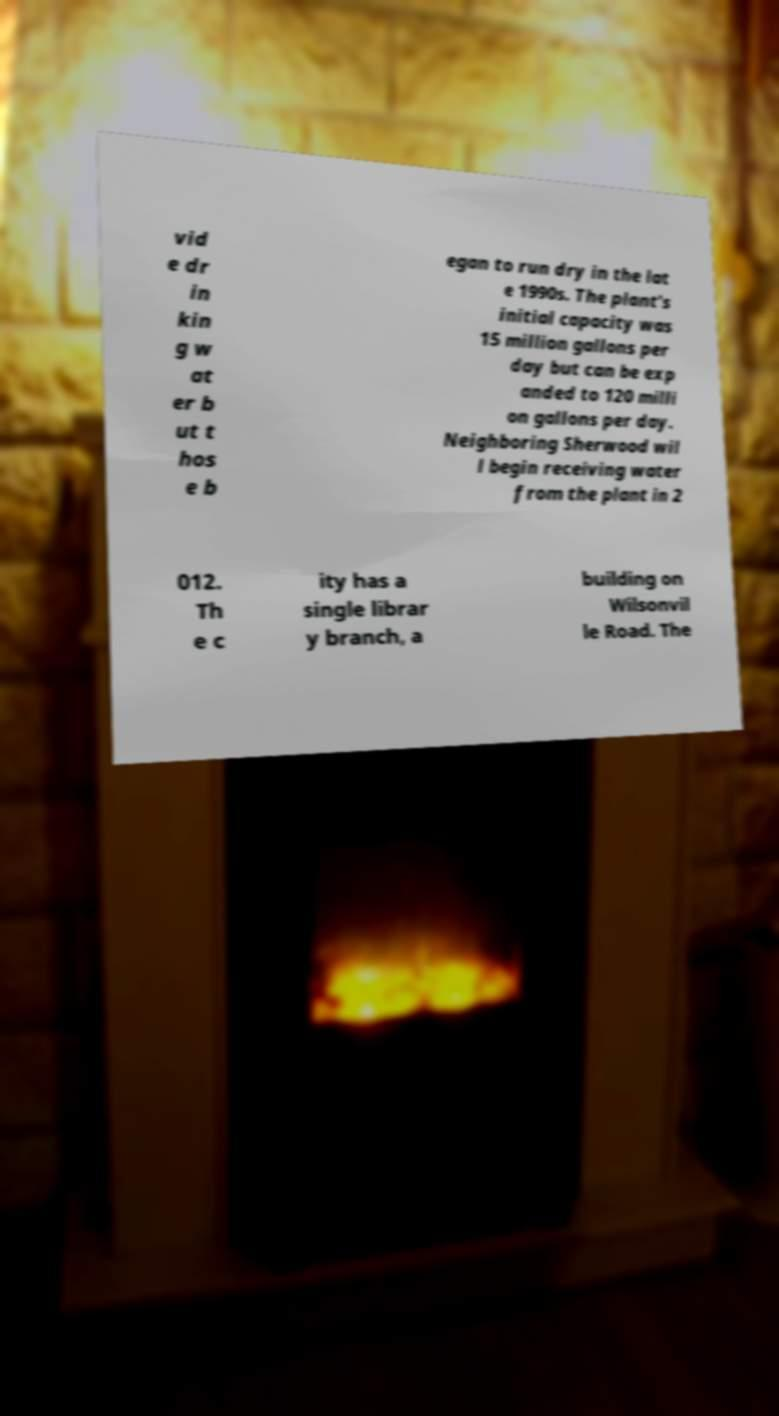Can you read and provide the text displayed in the image?This photo seems to have some interesting text. Can you extract and type it out for me? vid e dr in kin g w at er b ut t hos e b egan to run dry in the lat e 1990s. The plant's initial capacity was 15 million gallons per day but can be exp anded to 120 milli on gallons per day. Neighboring Sherwood wil l begin receiving water from the plant in 2 012. Th e c ity has a single librar y branch, a building on Wilsonvil le Road. The 